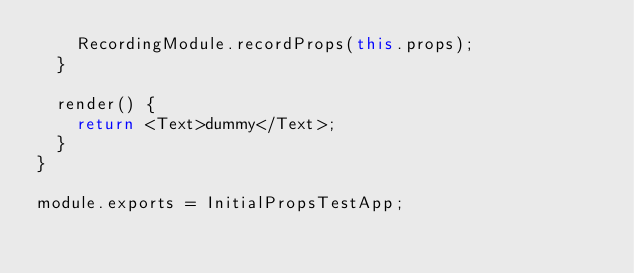Convert code to text. <code><loc_0><loc_0><loc_500><loc_500><_JavaScript_>    RecordingModule.recordProps(this.props);
  }

  render() {
    return <Text>dummy</Text>;
  }
}

module.exports = InitialPropsTestApp;
</code> 